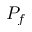<formula> <loc_0><loc_0><loc_500><loc_500>P _ { f }</formula> 